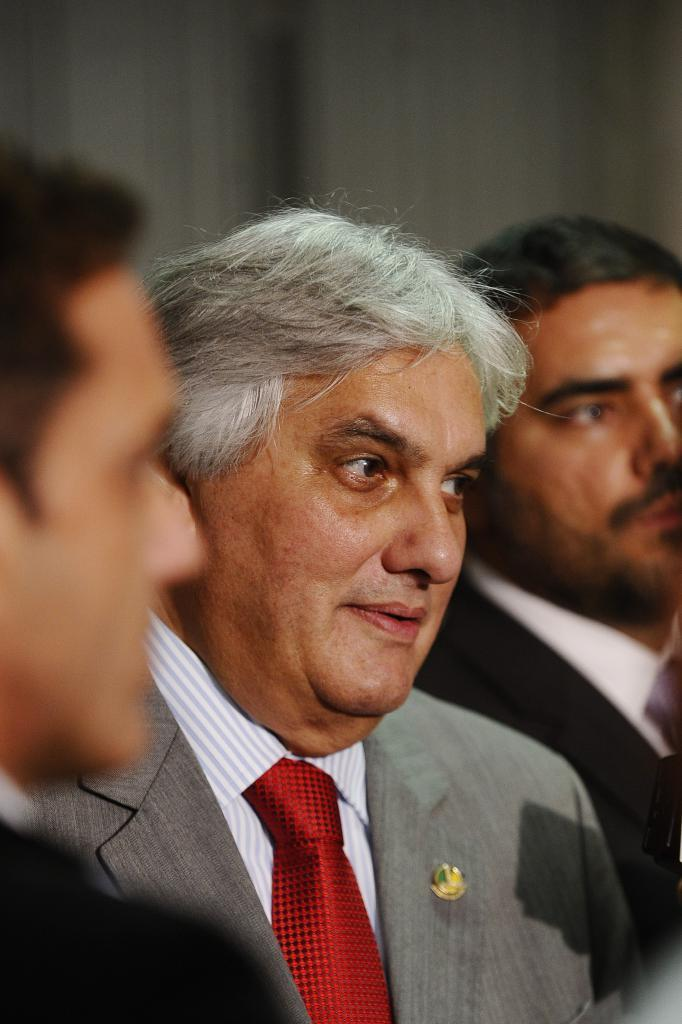How many people are present in the image? There are three people in the image. What is the attire of one of the individuals? One person is wearing a suit. In which direction is the person in the suit looking? The person in the suit is looking to the right. Can you describe the color of the background in the image? The background of the image has an ash color. What type of pest can be seen crawling on the person in the suit in the image? There is no pest visible in the image, and no pest is crawling on the person in the suit. 